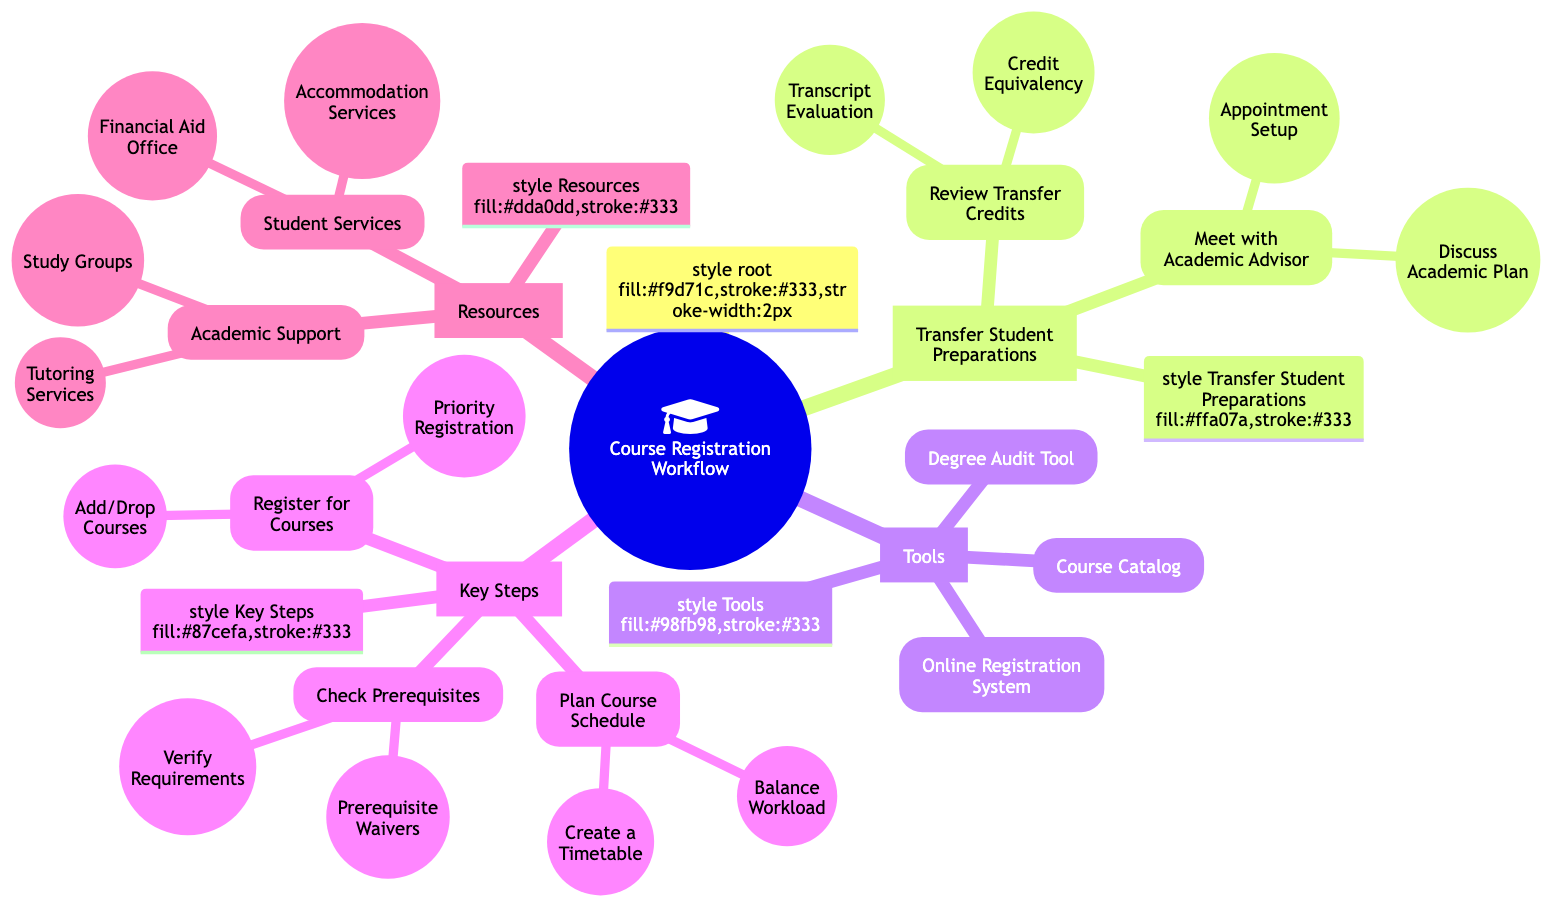What is the primary focus of the Mind Map? The Mind Map centers around the "Course Registration Workflow," indicated at the root of the diagram. This shows that all subsequent branches and topics relate back to this main theme.
Answer: Course Registration Workflow How many main branches are in the Mind Map? There are four main branches stemming from the root: Transfer Student Preparations, Tools, Key Steps, and Resources. Each branch represents a significant component of the course registration process.
Answer: 4 What does 'Transcript Evaluation' require? 'Transcript Evaluation' suggests that students should contact the Admissions Office, as indicated in the diagram. This is a necessary step in the process of reviewing transfer credits.
Answer: Contact Admissions Office Which tool is used to plan a course schedule? The Online Scheduling Tool is specified as the necessary resource for creating a timetable when planning the course schedule. This indicates a structured approach to organizing courses.
Answer: Online Scheduling Tool What is the first step to meet with an academic advisor? The first step in meeting with an academic advisor is to set up an appointment, which can be done via the Campus Portal according to the chart. This emphasizes the importance of planning ahead for academic guidance.
Answer: Schedule via Campus Portal How would a student know when to register for courses? Students can find out when to register for courses by checking dates on the Academic Calendar, as outlined in the 'Register for Courses' section of the diagram. This specific action helps students stay informed about essential timelines.
Answer: Check Dates on Academic Calendar What should a student use to verify course prerequisites? To verify course prerequisites, students should review the Course Catalog, which is indicated as the source for requirements necessary before enrolling in a course. This is a vital part of ensuring eligibility for courses.
Answer: Review Course Catalog What service can be accessed for study group opportunities? The diagram indicates that students can join study groups through Student Organizations, aligning this resource with academic support to enhance collaborative learning.
Answer: Join via Student Organizations 